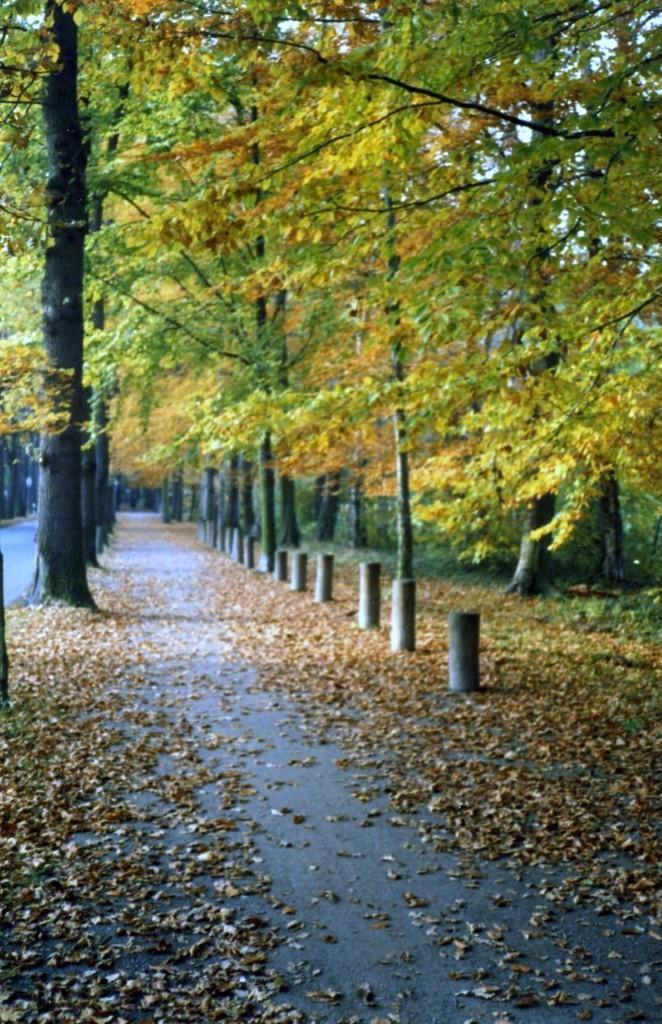Please provide a concise description of this image. In this image, we can see so many trees, poles, walkway, grass and leaves. 